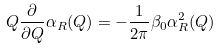<formula> <loc_0><loc_0><loc_500><loc_500>Q \frac { \partial } { \partial Q } \alpha _ { R } ( Q ) = - \frac { 1 } { 2 \pi } \beta _ { 0 } \alpha ^ { 2 } _ { R } ( Q )</formula> 